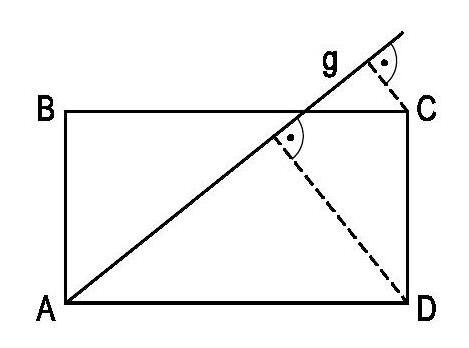Assume we don't have the lengths of AB or CD. Can we mathematically determine the length of AD without knowing these specific lengths? Absolutely! Even without the lengths of AB or CD, we can use the given information to determine the length of AD mathematically. Since AD is twice as long as AB, we can let AB = x and AD = 2x. By applying the principles of similar triangles and the fact that the perpendicular distances from C to g and D to g form a pair of parallel lines with CD, which provide us with two similar triangles, we can derive a proportional relationship. In this case, the ratio of the length of AD to the length of AB is proportional to the ratio of the perpendicular distances, such that (2x/x) = (6/2). Solving for x provides us the value of AB, which can then be multiplied by 2 to get the length of AD. 